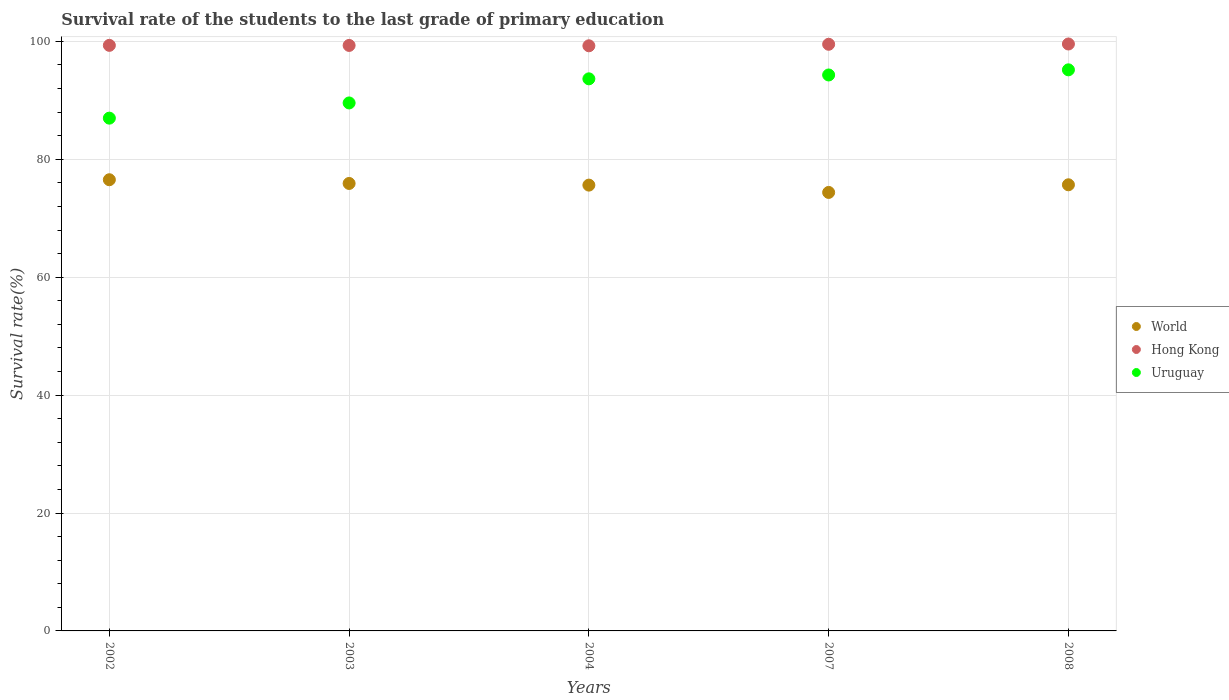How many different coloured dotlines are there?
Provide a succinct answer. 3. What is the survival rate of the students in Hong Kong in 2004?
Provide a succinct answer. 99.26. Across all years, what is the maximum survival rate of the students in Uruguay?
Offer a terse response. 95.18. Across all years, what is the minimum survival rate of the students in Uruguay?
Your answer should be compact. 86.98. In which year was the survival rate of the students in Uruguay minimum?
Your answer should be compact. 2002. What is the total survival rate of the students in World in the graph?
Provide a succinct answer. 378.12. What is the difference between the survival rate of the students in World in 2004 and that in 2008?
Your answer should be very brief. -0.06. What is the difference between the survival rate of the students in Uruguay in 2003 and the survival rate of the students in Hong Kong in 2007?
Make the answer very short. -9.95. What is the average survival rate of the students in World per year?
Give a very brief answer. 75.62. In the year 2002, what is the difference between the survival rate of the students in Uruguay and survival rate of the students in World?
Make the answer very short. 10.45. What is the ratio of the survival rate of the students in Hong Kong in 2003 to that in 2008?
Your response must be concise. 1. Is the difference between the survival rate of the students in Uruguay in 2003 and 2007 greater than the difference between the survival rate of the students in World in 2003 and 2007?
Provide a short and direct response. No. What is the difference between the highest and the second highest survival rate of the students in World?
Offer a very short reply. 0.63. What is the difference between the highest and the lowest survival rate of the students in Uruguay?
Provide a short and direct response. 8.2. Is the sum of the survival rate of the students in World in 2003 and 2007 greater than the maximum survival rate of the students in Uruguay across all years?
Your response must be concise. Yes. Is the survival rate of the students in Uruguay strictly less than the survival rate of the students in Hong Kong over the years?
Your answer should be very brief. Yes. Are the values on the major ticks of Y-axis written in scientific E-notation?
Your response must be concise. No. Does the graph contain grids?
Your answer should be compact. Yes. What is the title of the graph?
Offer a very short reply. Survival rate of the students to the last grade of primary education. Does "Cyprus" appear as one of the legend labels in the graph?
Provide a short and direct response. No. What is the label or title of the X-axis?
Offer a terse response. Years. What is the label or title of the Y-axis?
Provide a succinct answer. Survival rate(%). What is the Survival rate(%) in World in 2002?
Your answer should be compact. 76.53. What is the Survival rate(%) in Hong Kong in 2002?
Ensure brevity in your answer.  99.33. What is the Survival rate(%) of Uruguay in 2002?
Make the answer very short. 86.98. What is the Survival rate(%) of World in 2003?
Your answer should be compact. 75.9. What is the Survival rate(%) of Hong Kong in 2003?
Make the answer very short. 99.32. What is the Survival rate(%) in Uruguay in 2003?
Offer a terse response. 89.56. What is the Survival rate(%) in World in 2004?
Offer a very short reply. 75.62. What is the Survival rate(%) in Hong Kong in 2004?
Your answer should be very brief. 99.26. What is the Survival rate(%) of Uruguay in 2004?
Make the answer very short. 93.65. What is the Survival rate(%) in World in 2007?
Offer a very short reply. 74.38. What is the Survival rate(%) of Hong Kong in 2007?
Your answer should be very brief. 99.51. What is the Survival rate(%) of Uruguay in 2007?
Provide a short and direct response. 94.31. What is the Survival rate(%) in World in 2008?
Give a very brief answer. 75.68. What is the Survival rate(%) in Hong Kong in 2008?
Your response must be concise. 99.56. What is the Survival rate(%) of Uruguay in 2008?
Your answer should be very brief. 95.18. Across all years, what is the maximum Survival rate(%) of World?
Ensure brevity in your answer.  76.53. Across all years, what is the maximum Survival rate(%) of Hong Kong?
Your answer should be compact. 99.56. Across all years, what is the maximum Survival rate(%) in Uruguay?
Your answer should be compact. 95.18. Across all years, what is the minimum Survival rate(%) in World?
Ensure brevity in your answer.  74.38. Across all years, what is the minimum Survival rate(%) of Hong Kong?
Provide a succinct answer. 99.26. Across all years, what is the minimum Survival rate(%) in Uruguay?
Your answer should be compact. 86.98. What is the total Survival rate(%) in World in the graph?
Provide a short and direct response. 378.12. What is the total Survival rate(%) of Hong Kong in the graph?
Provide a short and direct response. 496.98. What is the total Survival rate(%) in Uruguay in the graph?
Your answer should be compact. 459.68. What is the difference between the Survival rate(%) in World in 2002 and that in 2003?
Offer a very short reply. 0.63. What is the difference between the Survival rate(%) of Hong Kong in 2002 and that in 2003?
Make the answer very short. 0.01. What is the difference between the Survival rate(%) in Uruguay in 2002 and that in 2003?
Make the answer very short. -2.58. What is the difference between the Survival rate(%) in World in 2002 and that in 2004?
Give a very brief answer. 0.91. What is the difference between the Survival rate(%) of Hong Kong in 2002 and that in 2004?
Your answer should be very brief. 0.07. What is the difference between the Survival rate(%) in Uruguay in 2002 and that in 2004?
Ensure brevity in your answer.  -6.67. What is the difference between the Survival rate(%) in World in 2002 and that in 2007?
Ensure brevity in your answer.  2.15. What is the difference between the Survival rate(%) of Hong Kong in 2002 and that in 2007?
Your answer should be very brief. -0.18. What is the difference between the Survival rate(%) of Uruguay in 2002 and that in 2007?
Offer a very short reply. -7.32. What is the difference between the Survival rate(%) in World in 2002 and that in 2008?
Offer a terse response. 0.86. What is the difference between the Survival rate(%) in Hong Kong in 2002 and that in 2008?
Your answer should be very brief. -0.23. What is the difference between the Survival rate(%) of Uruguay in 2002 and that in 2008?
Offer a terse response. -8.2. What is the difference between the Survival rate(%) of World in 2003 and that in 2004?
Your response must be concise. 0.28. What is the difference between the Survival rate(%) in Hong Kong in 2003 and that in 2004?
Your response must be concise. 0.06. What is the difference between the Survival rate(%) in Uruguay in 2003 and that in 2004?
Your answer should be compact. -4.09. What is the difference between the Survival rate(%) in World in 2003 and that in 2007?
Ensure brevity in your answer.  1.52. What is the difference between the Survival rate(%) in Hong Kong in 2003 and that in 2007?
Make the answer very short. -0.2. What is the difference between the Survival rate(%) of Uruguay in 2003 and that in 2007?
Provide a short and direct response. -4.75. What is the difference between the Survival rate(%) of World in 2003 and that in 2008?
Give a very brief answer. 0.23. What is the difference between the Survival rate(%) in Hong Kong in 2003 and that in 2008?
Give a very brief answer. -0.24. What is the difference between the Survival rate(%) in Uruguay in 2003 and that in 2008?
Your answer should be very brief. -5.62. What is the difference between the Survival rate(%) of World in 2004 and that in 2007?
Your answer should be compact. 1.24. What is the difference between the Survival rate(%) of Hong Kong in 2004 and that in 2007?
Ensure brevity in your answer.  -0.26. What is the difference between the Survival rate(%) in Uruguay in 2004 and that in 2007?
Provide a succinct answer. -0.66. What is the difference between the Survival rate(%) of World in 2004 and that in 2008?
Your answer should be very brief. -0.06. What is the difference between the Survival rate(%) of Hong Kong in 2004 and that in 2008?
Provide a succinct answer. -0.3. What is the difference between the Survival rate(%) in Uruguay in 2004 and that in 2008?
Ensure brevity in your answer.  -1.53. What is the difference between the Survival rate(%) of World in 2007 and that in 2008?
Make the answer very short. -1.3. What is the difference between the Survival rate(%) of Hong Kong in 2007 and that in 2008?
Your answer should be compact. -0.05. What is the difference between the Survival rate(%) of Uruguay in 2007 and that in 2008?
Provide a succinct answer. -0.87. What is the difference between the Survival rate(%) in World in 2002 and the Survival rate(%) in Hong Kong in 2003?
Keep it short and to the point. -22.78. What is the difference between the Survival rate(%) in World in 2002 and the Survival rate(%) in Uruguay in 2003?
Ensure brevity in your answer.  -13.03. What is the difference between the Survival rate(%) of Hong Kong in 2002 and the Survival rate(%) of Uruguay in 2003?
Ensure brevity in your answer.  9.77. What is the difference between the Survival rate(%) of World in 2002 and the Survival rate(%) of Hong Kong in 2004?
Provide a succinct answer. -22.72. What is the difference between the Survival rate(%) in World in 2002 and the Survival rate(%) in Uruguay in 2004?
Provide a short and direct response. -17.12. What is the difference between the Survival rate(%) in Hong Kong in 2002 and the Survival rate(%) in Uruguay in 2004?
Offer a terse response. 5.68. What is the difference between the Survival rate(%) of World in 2002 and the Survival rate(%) of Hong Kong in 2007?
Offer a terse response. -22.98. What is the difference between the Survival rate(%) of World in 2002 and the Survival rate(%) of Uruguay in 2007?
Give a very brief answer. -17.77. What is the difference between the Survival rate(%) of Hong Kong in 2002 and the Survival rate(%) of Uruguay in 2007?
Ensure brevity in your answer.  5.02. What is the difference between the Survival rate(%) of World in 2002 and the Survival rate(%) of Hong Kong in 2008?
Offer a terse response. -23.03. What is the difference between the Survival rate(%) of World in 2002 and the Survival rate(%) of Uruguay in 2008?
Keep it short and to the point. -18.64. What is the difference between the Survival rate(%) of Hong Kong in 2002 and the Survival rate(%) of Uruguay in 2008?
Offer a very short reply. 4.15. What is the difference between the Survival rate(%) in World in 2003 and the Survival rate(%) in Hong Kong in 2004?
Your answer should be very brief. -23.35. What is the difference between the Survival rate(%) of World in 2003 and the Survival rate(%) of Uruguay in 2004?
Make the answer very short. -17.75. What is the difference between the Survival rate(%) in Hong Kong in 2003 and the Survival rate(%) in Uruguay in 2004?
Make the answer very short. 5.67. What is the difference between the Survival rate(%) in World in 2003 and the Survival rate(%) in Hong Kong in 2007?
Provide a succinct answer. -23.61. What is the difference between the Survival rate(%) in World in 2003 and the Survival rate(%) in Uruguay in 2007?
Make the answer very short. -18.4. What is the difference between the Survival rate(%) of Hong Kong in 2003 and the Survival rate(%) of Uruguay in 2007?
Offer a very short reply. 5.01. What is the difference between the Survival rate(%) of World in 2003 and the Survival rate(%) of Hong Kong in 2008?
Your response must be concise. -23.66. What is the difference between the Survival rate(%) of World in 2003 and the Survival rate(%) of Uruguay in 2008?
Make the answer very short. -19.27. What is the difference between the Survival rate(%) of Hong Kong in 2003 and the Survival rate(%) of Uruguay in 2008?
Provide a succinct answer. 4.14. What is the difference between the Survival rate(%) in World in 2004 and the Survival rate(%) in Hong Kong in 2007?
Your answer should be compact. -23.89. What is the difference between the Survival rate(%) in World in 2004 and the Survival rate(%) in Uruguay in 2007?
Your answer should be very brief. -18.68. What is the difference between the Survival rate(%) in Hong Kong in 2004 and the Survival rate(%) in Uruguay in 2007?
Keep it short and to the point. 4.95. What is the difference between the Survival rate(%) of World in 2004 and the Survival rate(%) of Hong Kong in 2008?
Offer a terse response. -23.94. What is the difference between the Survival rate(%) of World in 2004 and the Survival rate(%) of Uruguay in 2008?
Offer a terse response. -19.56. What is the difference between the Survival rate(%) of Hong Kong in 2004 and the Survival rate(%) of Uruguay in 2008?
Your response must be concise. 4.08. What is the difference between the Survival rate(%) of World in 2007 and the Survival rate(%) of Hong Kong in 2008?
Provide a succinct answer. -25.18. What is the difference between the Survival rate(%) of World in 2007 and the Survival rate(%) of Uruguay in 2008?
Your answer should be compact. -20.8. What is the difference between the Survival rate(%) in Hong Kong in 2007 and the Survival rate(%) in Uruguay in 2008?
Provide a succinct answer. 4.34. What is the average Survival rate(%) in World per year?
Ensure brevity in your answer.  75.62. What is the average Survival rate(%) of Hong Kong per year?
Offer a terse response. 99.4. What is the average Survival rate(%) of Uruguay per year?
Offer a terse response. 91.94. In the year 2002, what is the difference between the Survival rate(%) of World and Survival rate(%) of Hong Kong?
Offer a terse response. -22.79. In the year 2002, what is the difference between the Survival rate(%) in World and Survival rate(%) in Uruguay?
Give a very brief answer. -10.45. In the year 2002, what is the difference between the Survival rate(%) in Hong Kong and Survival rate(%) in Uruguay?
Make the answer very short. 12.35. In the year 2003, what is the difference between the Survival rate(%) of World and Survival rate(%) of Hong Kong?
Provide a succinct answer. -23.41. In the year 2003, what is the difference between the Survival rate(%) in World and Survival rate(%) in Uruguay?
Offer a terse response. -13.66. In the year 2003, what is the difference between the Survival rate(%) of Hong Kong and Survival rate(%) of Uruguay?
Offer a very short reply. 9.76. In the year 2004, what is the difference between the Survival rate(%) in World and Survival rate(%) in Hong Kong?
Offer a very short reply. -23.63. In the year 2004, what is the difference between the Survival rate(%) of World and Survival rate(%) of Uruguay?
Ensure brevity in your answer.  -18.03. In the year 2004, what is the difference between the Survival rate(%) of Hong Kong and Survival rate(%) of Uruguay?
Give a very brief answer. 5.6. In the year 2007, what is the difference between the Survival rate(%) of World and Survival rate(%) of Hong Kong?
Give a very brief answer. -25.13. In the year 2007, what is the difference between the Survival rate(%) in World and Survival rate(%) in Uruguay?
Provide a succinct answer. -19.92. In the year 2007, what is the difference between the Survival rate(%) in Hong Kong and Survival rate(%) in Uruguay?
Make the answer very short. 5.21. In the year 2008, what is the difference between the Survival rate(%) in World and Survival rate(%) in Hong Kong?
Your answer should be compact. -23.88. In the year 2008, what is the difference between the Survival rate(%) in World and Survival rate(%) in Uruguay?
Offer a very short reply. -19.5. In the year 2008, what is the difference between the Survival rate(%) in Hong Kong and Survival rate(%) in Uruguay?
Give a very brief answer. 4.38. What is the ratio of the Survival rate(%) of World in 2002 to that in 2003?
Provide a succinct answer. 1.01. What is the ratio of the Survival rate(%) in Hong Kong in 2002 to that in 2003?
Keep it short and to the point. 1. What is the ratio of the Survival rate(%) in Uruguay in 2002 to that in 2003?
Ensure brevity in your answer.  0.97. What is the ratio of the Survival rate(%) of World in 2002 to that in 2004?
Offer a terse response. 1.01. What is the ratio of the Survival rate(%) in Uruguay in 2002 to that in 2004?
Provide a succinct answer. 0.93. What is the ratio of the Survival rate(%) in World in 2002 to that in 2007?
Keep it short and to the point. 1.03. What is the ratio of the Survival rate(%) of Uruguay in 2002 to that in 2007?
Provide a succinct answer. 0.92. What is the ratio of the Survival rate(%) in World in 2002 to that in 2008?
Offer a very short reply. 1.01. What is the ratio of the Survival rate(%) in Uruguay in 2002 to that in 2008?
Your response must be concise. 0.91. What is the ratio of the Survival rate(%) in World in 2003 to that in 2004?
Give a very brief answer. 1. What is the ratio of the Survival rate(%) in Hong Kong in 2003 to that in 2004?
Give a very brief answer. 1. What is the ratio of the Survival rate(%) of Uruguay in 2003 to that in 2004?
Offer a terse response. 0.96. What is the ratio of the Survival rate(%) of World in 2003 to that in 2007?
Your response must be concise. 1.02. What is the ratio of the Survival rate(%) of Uruguay in 2003 to that in 2007?
Offer a terse response. 0.95. What is the ratio of the Survival rate(%) in Uruguay in 2003 to that in 2008?
Offer a very short reply. 0.94. What is the ratio of the Survival rate(%) in World in 2004 to that in 2007?
Ensure brevity in your answer.  1.02. What is the ratio of the Survival rate(%) of Hong Kong in 2004 to that in 2007?
Your response must be concise. 1. What is the ratio of the Survival rate(%) in World in 2004 to that in 2008?
Keep it short and to the point. 1. What is the ratio of the Survival rate(%) of Hong Kong in 2004 to that in 2008?
Your response must be concise. 1. What is the ratio of the Survival rate(%) in World in 2007 to that in 2008?
Give a very brief answer. 0.98. What is the ratio of the Survival rate(%) in Hong Kong in 2007 to that in 2008?
Offer a very short reply. 1. What is the difference between the highest and the second highest Survival rate(%) of World?
Offer a very short reply. 0.63. What is the difference between the highest and the second highest Survival rate(%) in Hong Kong?
Provide a succinct answer. 0.05. What is the difference between the highest and the second highest Survival rate(%) of Uruguay?
Ensure brevity in your answer.  0.87. What is the difference between the highest and the lowest Survival rate(%) of World?
Provide a short and direct response. 2.15. What is the difference between the highest and the lowest Survival rate(%) in Hong Kong?
Your answer should be compact. 0.3. What is the difference between the highest and the lowest Survival rate(%) of Uruguay?
Give a very brief answer. 8.2. 